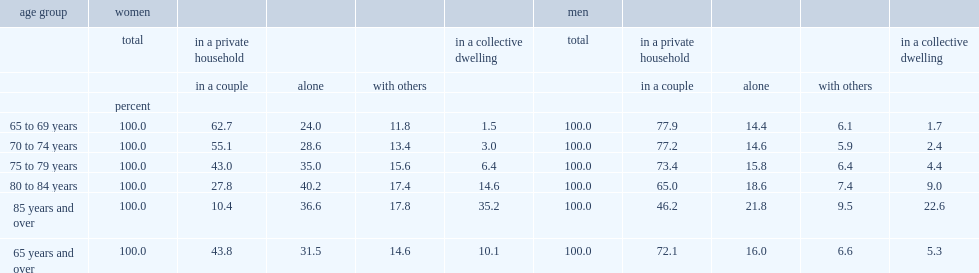What was the percent of senior women were part of a couple in 2011? 43.8. What was the percent of senior men were part of a couple in 2011? 72.1. What was the percent of most women in their late sixties were part of a couple? 62.7. What was the percent of most men in their late sixties were part of a couple? 77.9. The share dropped with age, and by age 85 and over, what was the percent of women were part of a couple? 10.4. At age 85 and over, what was the percent of men were part of a couple? 46.2. What was the percent of women aged 75 to 79 were part of a couple in 2011? 43.0. 